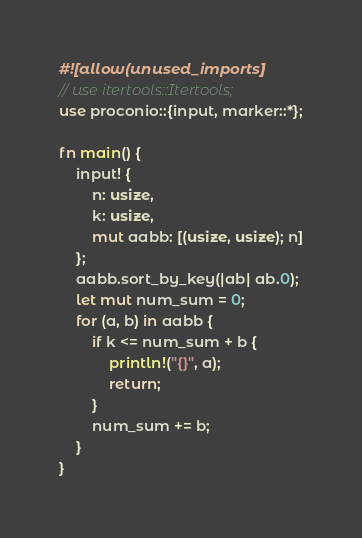<code> <loc_0><loc_0><loc_500><loc_500><_Rust_>#![allow(unused_imports)]
// use itertools::Itertools;
use proconio::{input, marker::*};

fn main() {
    input! {
        n: usize,
        k: usize,
        mut aabb: [(usize, usize); n]
    };
    aabb.sort_by_key(|ab| ab.0);
    let mut num_sum = 0;
    for (a, b) in aabb {
        if k <= num_sum + b {
            println!("{}", a);
            return;
        }
        num_sum += b;
    }
}
</code> 